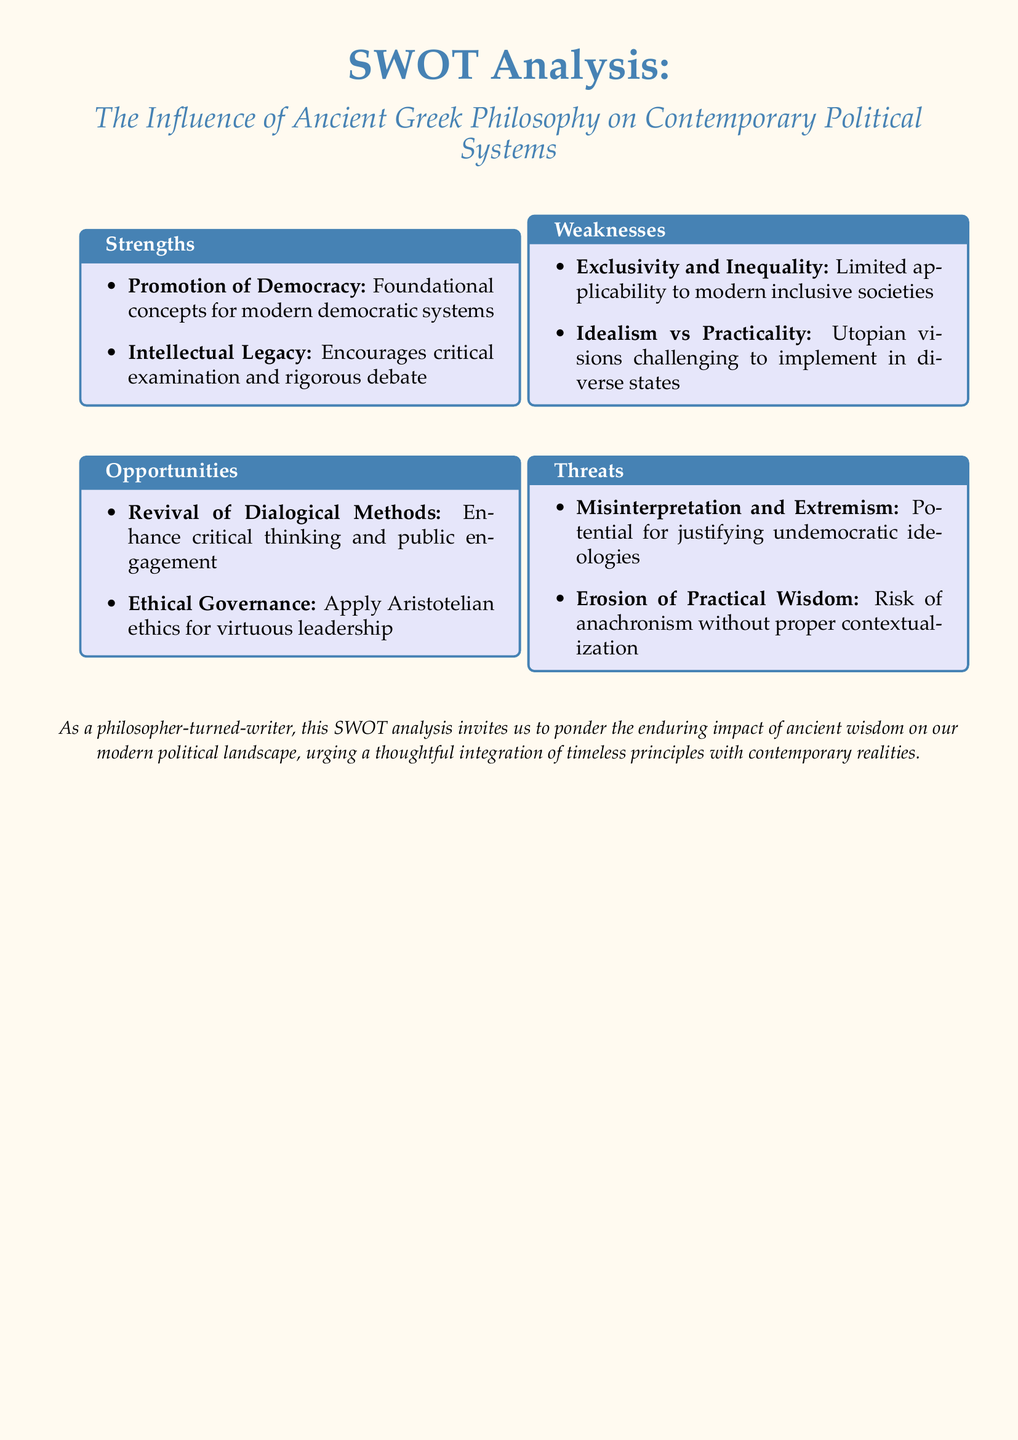What are the foundational concepts for modern democratic systems? The SWOT analysis identifies "Promotion of Democracy" as a strength, suggesting it refers to the foundational concepts for modern democratic systems.
Answer: Promotion of Democracy What ethical framework is suggested for virtuous leadership? The document recommends applying "Aristotelian ethics" for virtuous leadership under the Opportunities section.
Answer: Aristotelian ethics What is one weakness related to applicability? The SWOT analysis notes "Exclusivity and Inequality" as a weakness, indicating limited applicability to modern inclusive societies.
Answer: Exclusivity and Inequality What challenge is associated with utopian visions? The document mentions "Idealism vs Practicality," suggesting that utopian visions can be challenging to implement in diverse states.
Answer: Idealism vs Practicality What threat involves misinterpretation? The analysis states "Misinterpretation and Extremism" as a threat, indicating the potential for justifying undemocratic ideologies.
Answer: Misinterpretation and Extremism Which method is proposed for enhancing critical thinking? The Opportunities section suggests the "Revival of Dialogical Methods" for enhancing critical thinking and public engagement.
Answer: Revival of Dialogical Methods What is the aim of the SWOT analysis? The document describes its purpose as inviting reflection on the impact of ancient wisdom on modern political landscapes.
Answer: Impact of ancient wisdom on modern political landscapes How many categories are included in this SWOT analysis? The document lists four categories: Strengths, Weaknesses, Opportunities, and Threats, totaling four distinct areas.
Answer: Four What does the analysis urge regarding ancient principles? The analysis urges a "thoughtful integration" of timeless principles with contemporary realities.
Answer: Thoughtful integration 